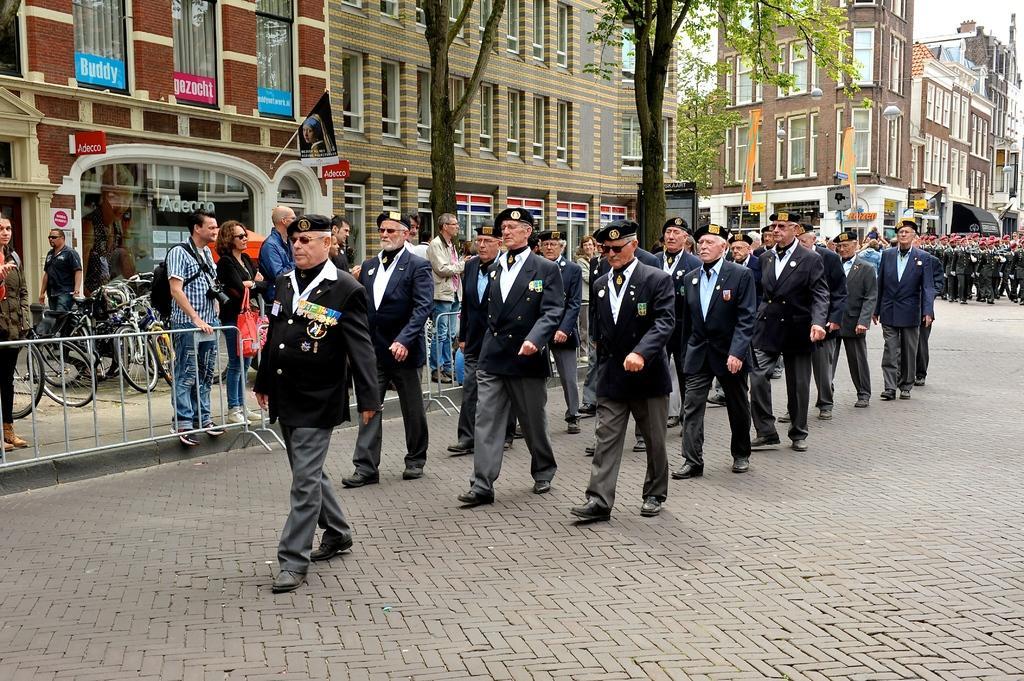Describe this image in one or two sentences. In this picture there are few persons wearing suit are standing and there is a fence,few persons,bicycles and buildings in the left corner and there are few persons and buildings in the right corner. 